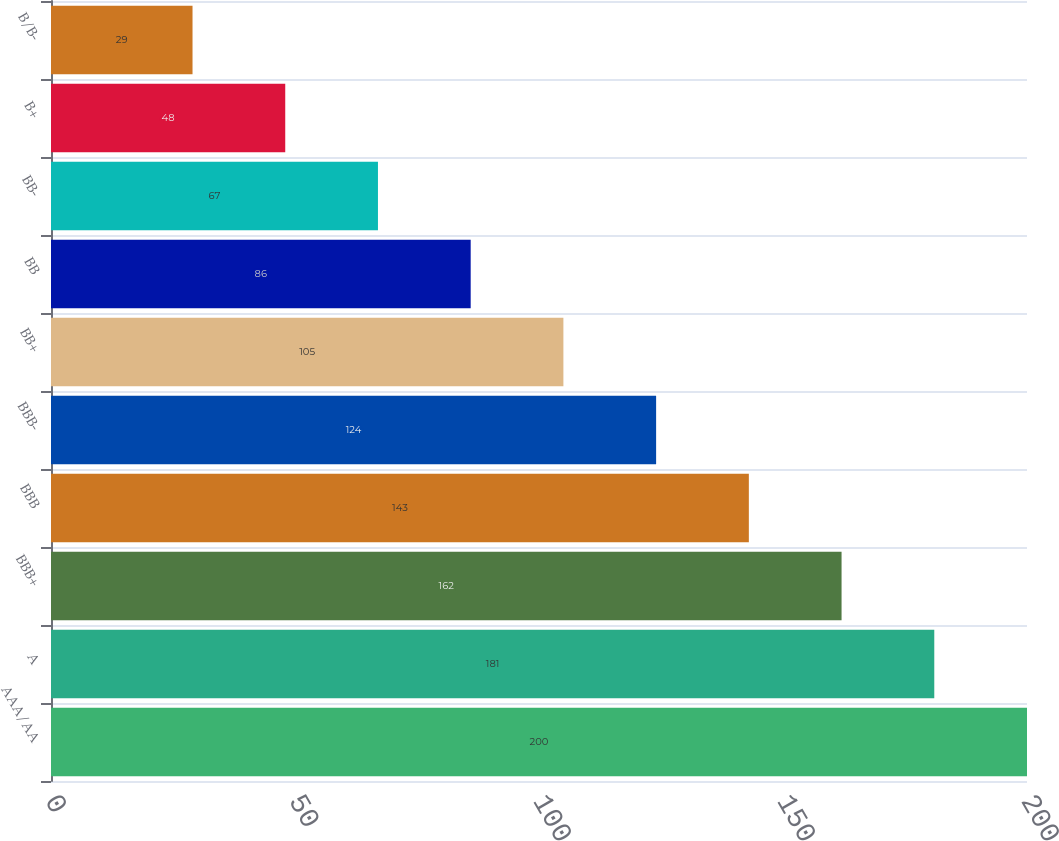Convert chart to OTSL. <chart><loc_0><loc_0><loc_500><loc_500><bar_chart><fcel>AAA/AA<fcel>A<fcel>BBB+<fcel>BBB<fcel>BBB-<fcel>BB+<fcel>BB<fcel>BB-<fcel>B+<fcel>B/B-<nl><fcel>200<fcel>181<fcel>162<fcel>143<fcel>124<fcel>105<fcel>86<fcel>67<fcel>48<fcel>29<nl></chart> 